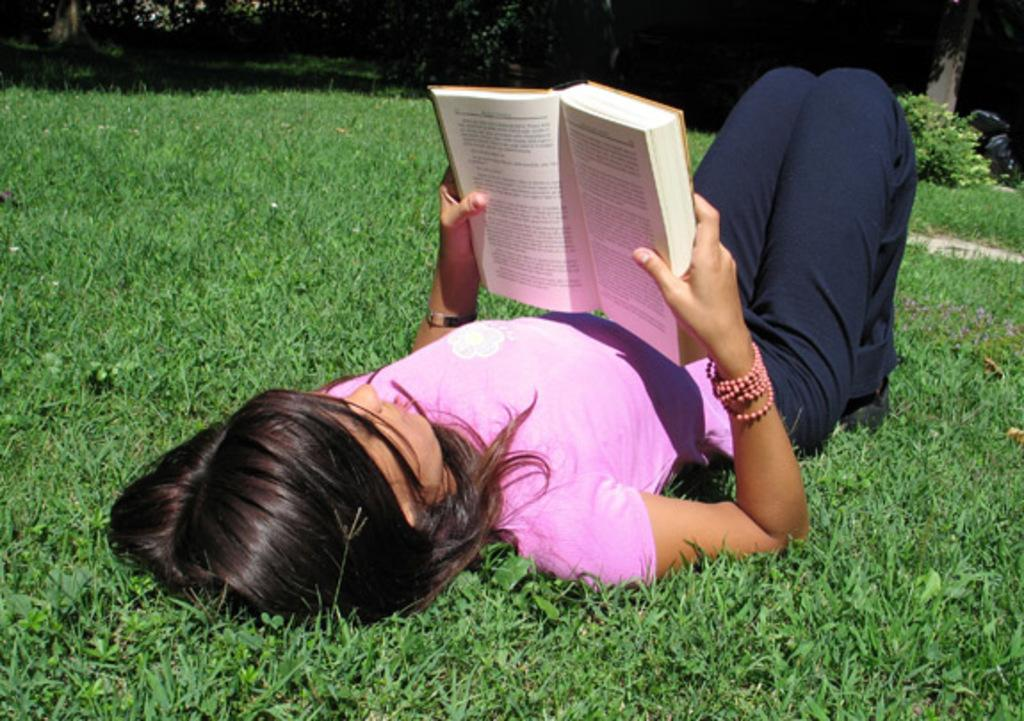Who is present in the image? There is a woman in the image. What is the woman doing in the image? The woman is lying down on the grass. What is the woman holding in her hands? The woman is holding a book in her hands. What type of suit is the crowd wearing in the image? There is no crowd present in the image, and therefore no suits can be observed. 